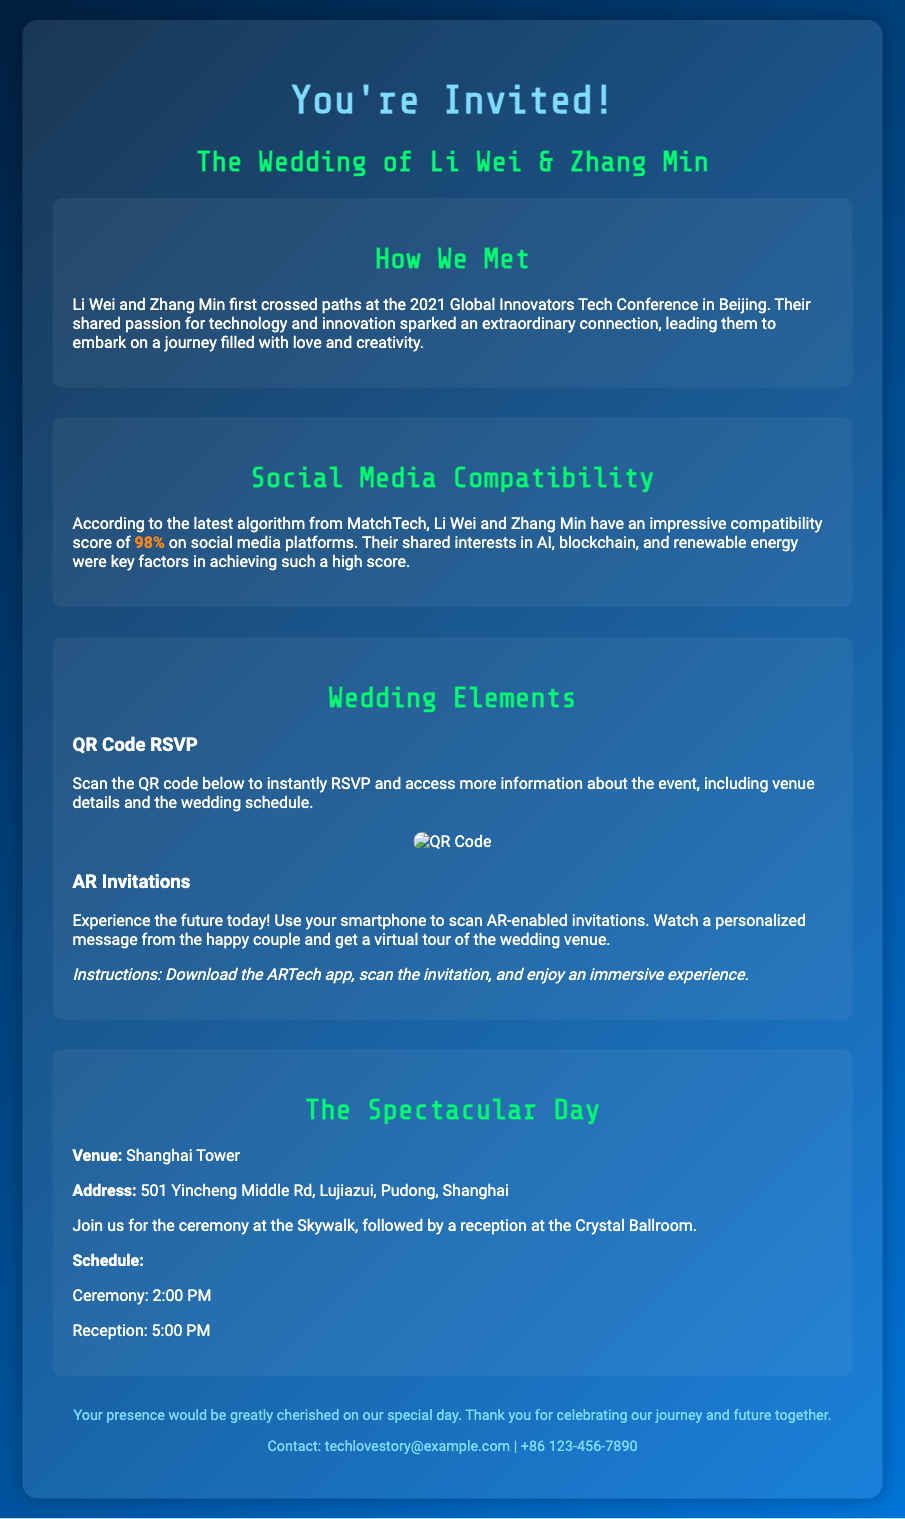what is the title of the invitation? The title of the invitation highlights the theme of the wedding, which is "A Tech Love Story: A Journey of Two Innovators."
Answer: A Tech Love Story: A Journey of Two Innovators who are the couple getting married? The invitation mentions the names of the couple getting married, which are Li Wei and Zhang Min.
Answer: Li Wei & Zhang Min where did Li Wei and Zhang Min meet? The document states that Li Wei and Zhang Min first met at the 2021 Global Innovators Tech Conference in Beijing.
Answer: 2021 Global Innovators Tech Conference, Beijing what is the social media compatibility score mentioned? The document provides a specific number representing the couple's compatibility score, which is 98%.
Answer: 98% what feature does the QR code provide? The QR code serves a specific purpose as described in the document, which is to RSVP and access more information about the event.
Answer: RSVP and access more information which app do you need to use for AR invitations? The document specifies a particular app that users must download to scan the AR-enabled invitations, which is the ARTech app.
Answer: ARTech app what is the venue of the wedding? The invitation includes the name of the venue where the wedding will take place, which is Shanghai Tower.
Answer: Shanghai Tower what time does the ceremony start? The wedding invitation states the time at which the ceremony will begin, which is 2:00 PM.
Answer: 2:00 PM 